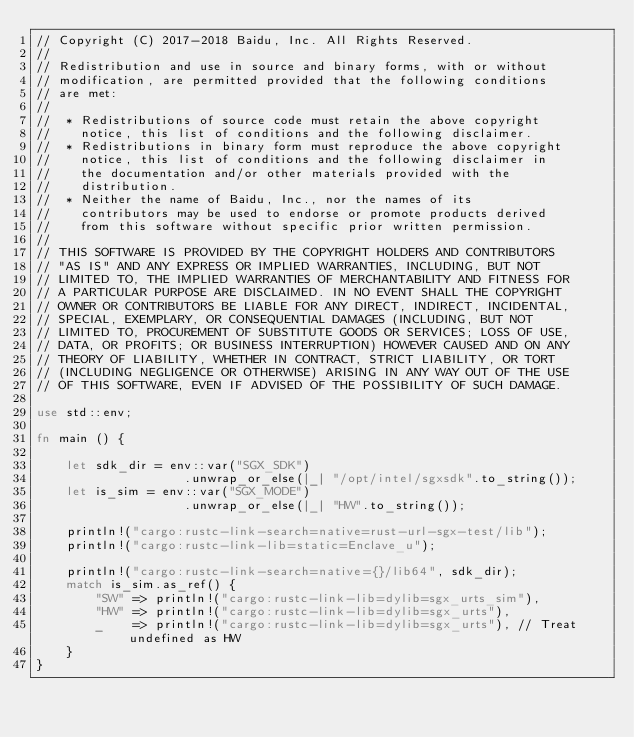Convert code to text. <code><loc_0><loc_0><loc_500><loc_500><_Rust_>// Copyright (C) 2017-2018 Baidu, Inc. All Rights Reserved.
//
// Redistribution and use in source and binary forms, with or without
// modification, are permitted provided that the following conditions
// are met:
//
//  * Redistributions of source code must retain the above copyright
//    notice, this list of conditions and the following disclaimer.
//  * Redistributions in binary form must reproduce the above copyright
//    notice, this list of conditions and the following disclaimer in
//    the documentation and/or other materials provided with the
//    distribution.
//  * Neither the name of Baidu, Inc., nor the names of its
//    contributors may be used to endorse or promote products derived
//    from this software without specific prior written permission.
//
// THIS SOFTWARE IS PROVIDED BY THE COPYRIGHT HOLDERS AND CONTRIBUTORS
// "AS IS" AND ANY EXPRESS OR IMPLIED WARRANTIES, INCLUDING, BUT NOT
// LIMITED TO, THE IMPLIED WARRANTIES OF MERCHANTABILITY AND FITNESS FOR
// A PARTICULAR PURPOSE ARE DISCLAIMED. IN NO EVENT SHALL THE COPYRIGHT
// OWNER OR CONTRIBUTORS BE LIABLE FOR ANY DIRECT, INDIRECT, INCIDENTAL,
// SPECIAL, EXEMPLARY, OR CONSEQUENTIAL DAMAGES (INCLUDING, BUT NOT
// LIMITED TO, PROCUREMENT OF SUBSTITUTE GOODS OR SERVICES; LOSS OF USE,
// DATA, OR PROFITS; OR BUSINESS INTERRUPTION) HOWEVER CAUSED AND ON ANY
// THEORY OF LIABILITY, WHETHER IN CONTRACT, STRICT LIABILITY, OR TORT
// (INCLUDING NEGLIGENCE OR OTHERWISE) ARISING IN ANY WAY OUT OF THE USE
// OF THIS SOFTWARE, EVEN IF ADVISED OF THE POSSIBILITY OF SUCH DAMAGE.

use std::env;

fn main () {

    let sdk_dir = env::var("SGX_SDK")
                    .unwrap_or_else(|_| "/opt/intel/sgxsdk".to_string());
    let is_sim = env::var("SGX_MODE")
                    .unwrap_or_else(|_| "HW".to_string());

    println!("cargo:rustc-link-search=native=rust-url-sgx-test/lib");
    println!("cargo:rustc-link-lib=static=Enclave_u");

    println!("cargo:rustc-link-search=native={}/lib64", sdk_dir);
    match is_sim.as_ref() {
        "SW" => println!("cargo:rustc-link-lib=dylib=sgx_urts_sim"),
        "HW" => println!("cargo:rustc-link-lib=dylib=sgx_urts"),
        _    => println!("cargo:rustc-link-lib=dylib=sgx_urts"), // Treat undefined as HW
    }
}
</code> 